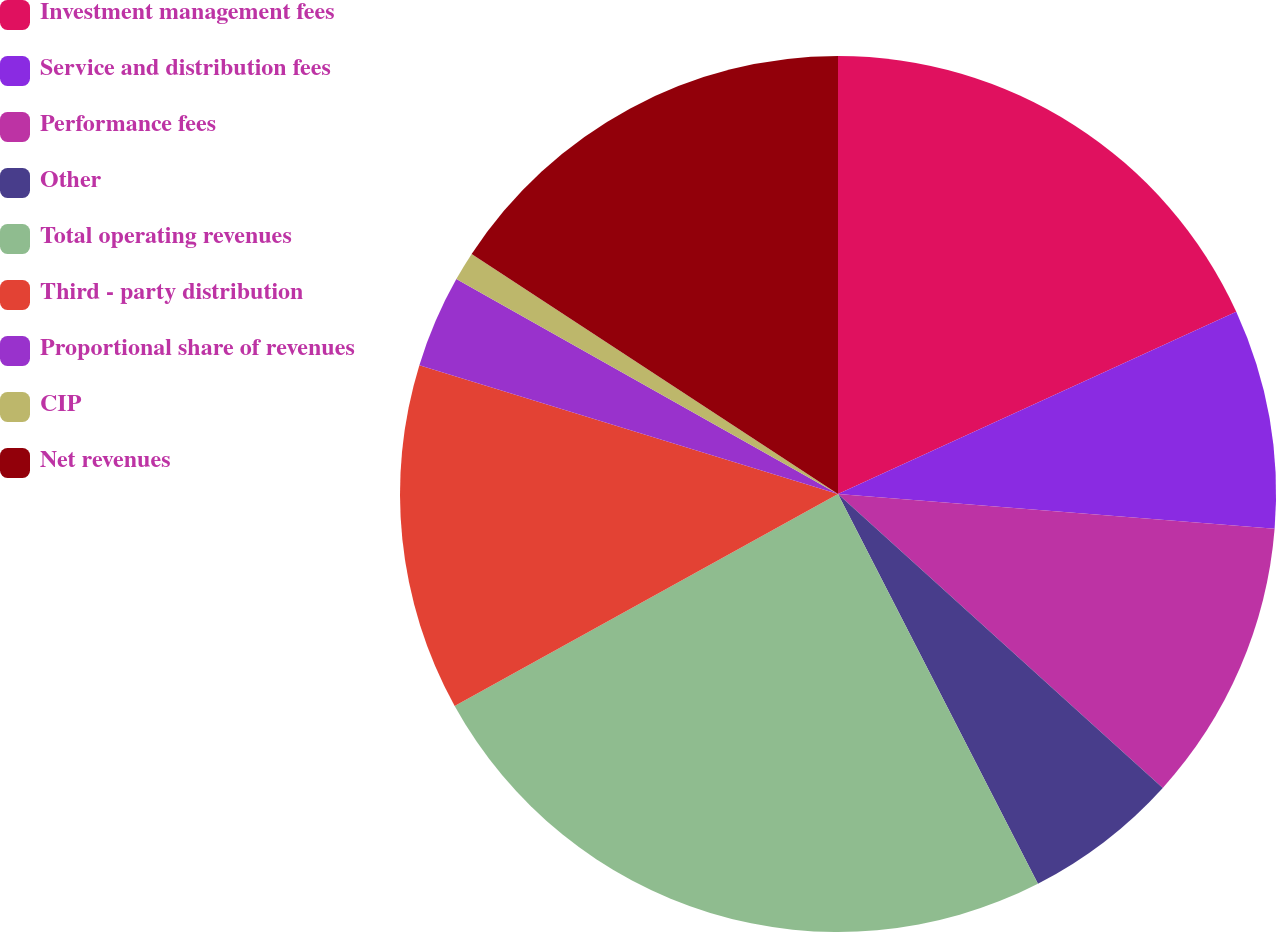<chart> <loc_0><loc_0><loc_500><loc_500><pie_chart><fcel>Investment management fees<fcel>Service and distribution fees<fcel>Performance fees<fcel>Other<fcel>Total operating revenues<fcel>Third - party distribution<fcel>Proportional share of revenues<fcel>CIP<fcel>Net revenues<nl><fcel>18.17%<fcel>8.1%<fcel>10.44%<fcel>5.75%<fcel>24.51%<fcel>12.79%<fcel>3.41%<fcel>1.07%<fcel>15.77%<nl></chart> 